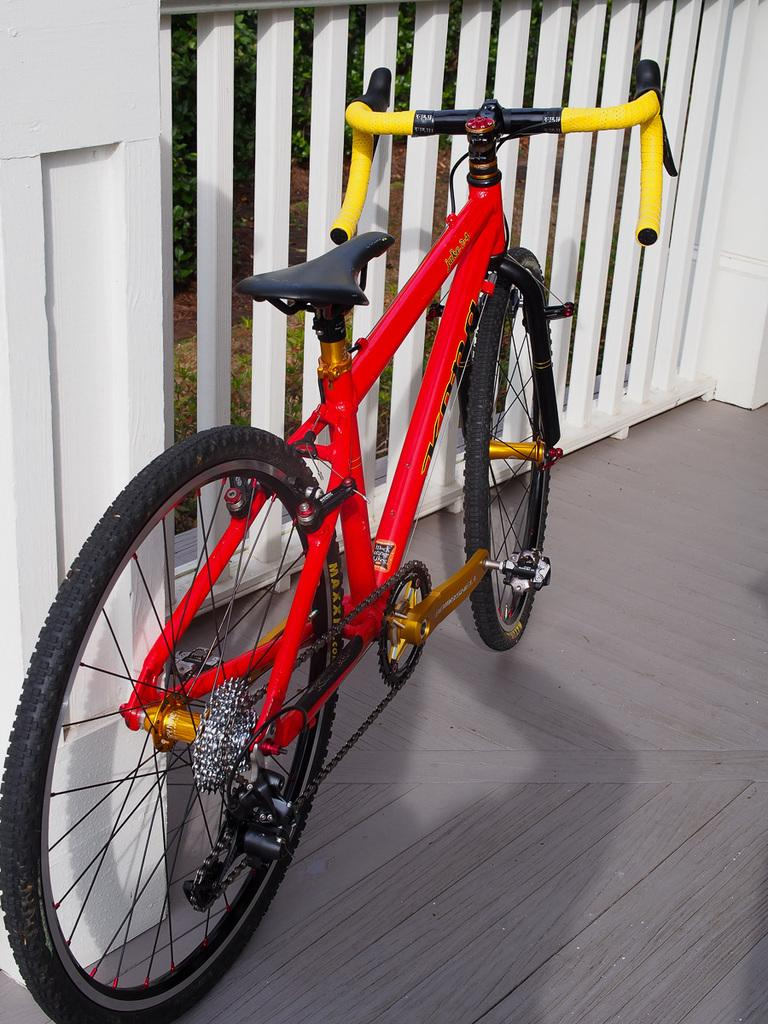What is the main subject of the image? The main subject of the image is a bicycle. What is located in front of the bicycle? There is a metal fence in front of the bicycle. What type of joke is being told by the corn in the image? There is no corn or joke present in the image; it features a bicycle and a metal fence. How many ants are crawling on the bicycle in the image? There are no ants present on the bicycle in the image. 